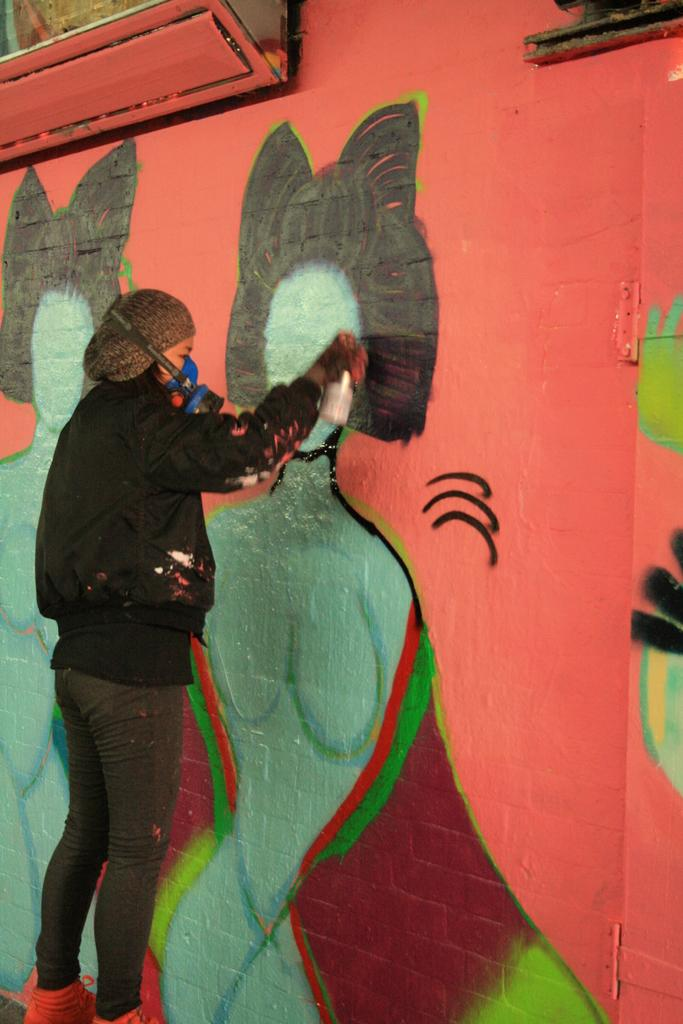What is the main subject of the image? There is a person in the image. What is the person doing in the image? The person is painting on a wall. What type of pancake is being used as a brush in the image? There is no pancake present in the image, and the person is using a traditional paintbrush or tool to paint on the wall. 